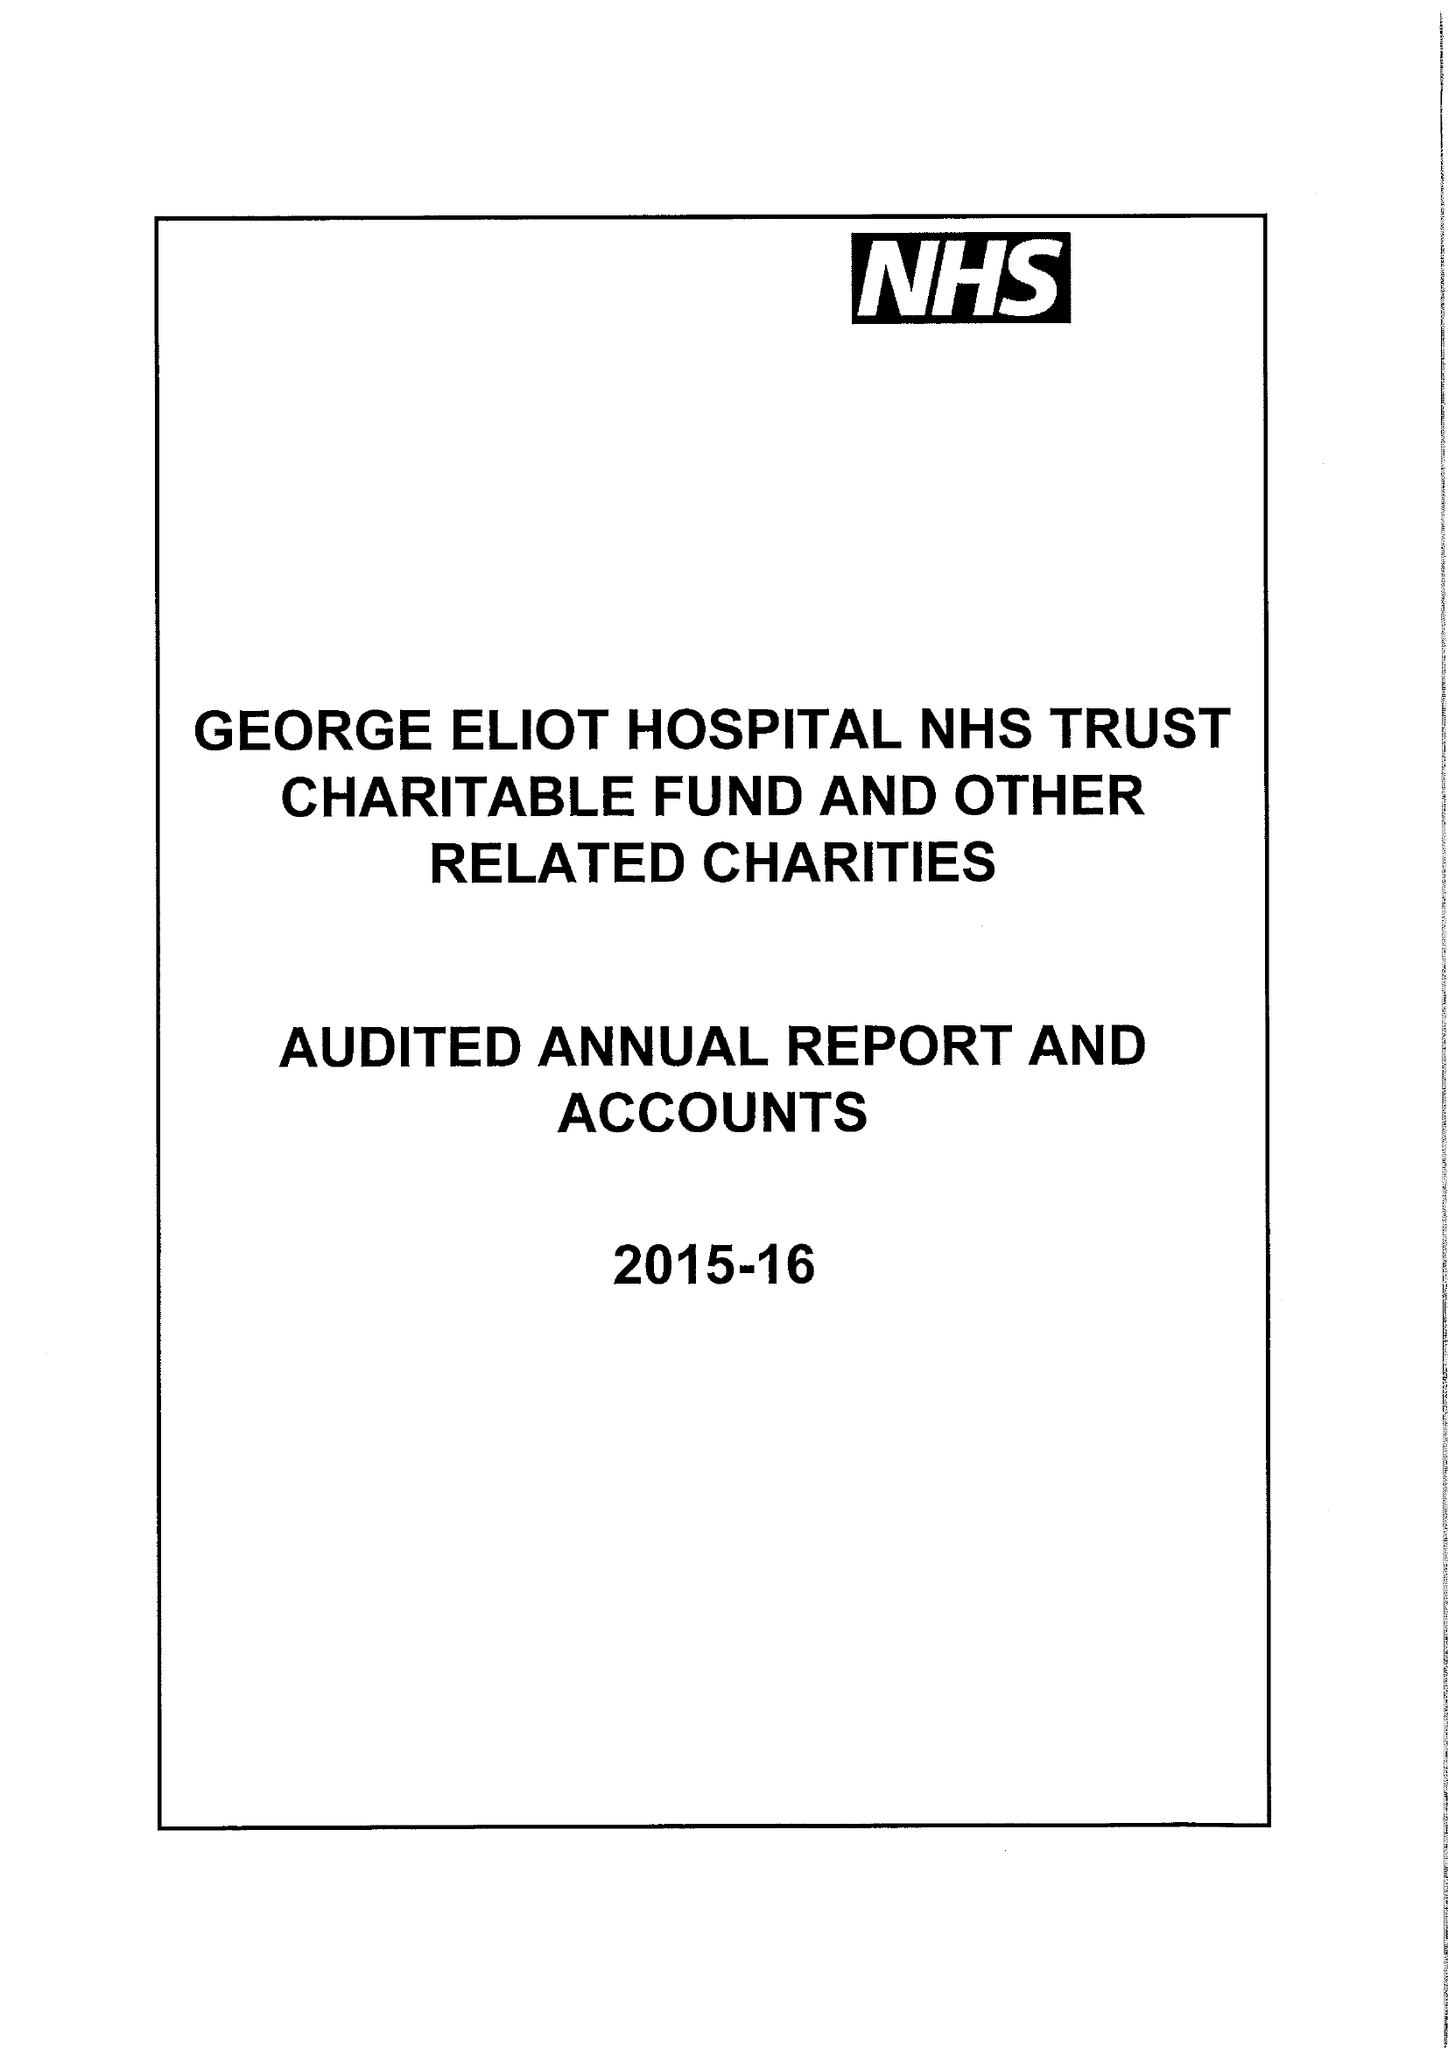What is the value for the income_annually_in_british_pounds?
Answer the question using a single word or phrase. 161000.00 